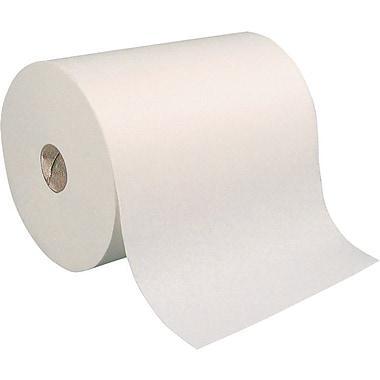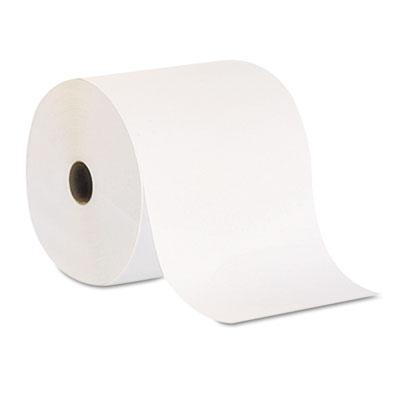The first image is the image on the left, the second image is the image on the right. Given the left and right images, does the statement "The right-hand roll is noticeably browner and darker in color." hold true? Answer yes or no. No. 